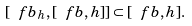<formula> <loc_0><loc_0><loc_500><loc_500>[ \ f b _ { h } , [ \ f b , h ] ] \subset [ \ f b , h ] .</formula> 